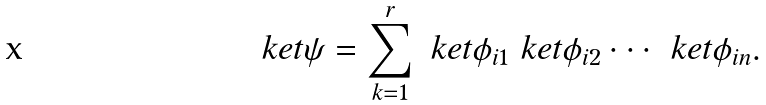<formula> <loc_0><loc_0><loc_500><loc_500>\ k e t { \psi } = \sum _ { k = 1 } ^ { r } \ k e t { \phi _ { i 1 } } \ k e t { \phi _ { i 2 } } \cdot \cdot \cdot \ k e t { \phi _ { i n } } .</formula> 